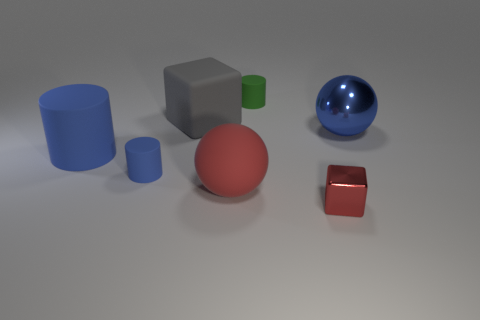Add 2 shiny balls. How many objects exist? 9 Subtract all cubes. How many objects are left? 5 Subtract 0 purple blocks. How many objects are left? 7 Subtract all tiny cubes. Subtract all brown matte spheres. How many objects are left? 6 Add 1 metallic blocks. How many metallic blocks are left? 2 Add 5 shiny objects. How many shiny objects exist? 7 